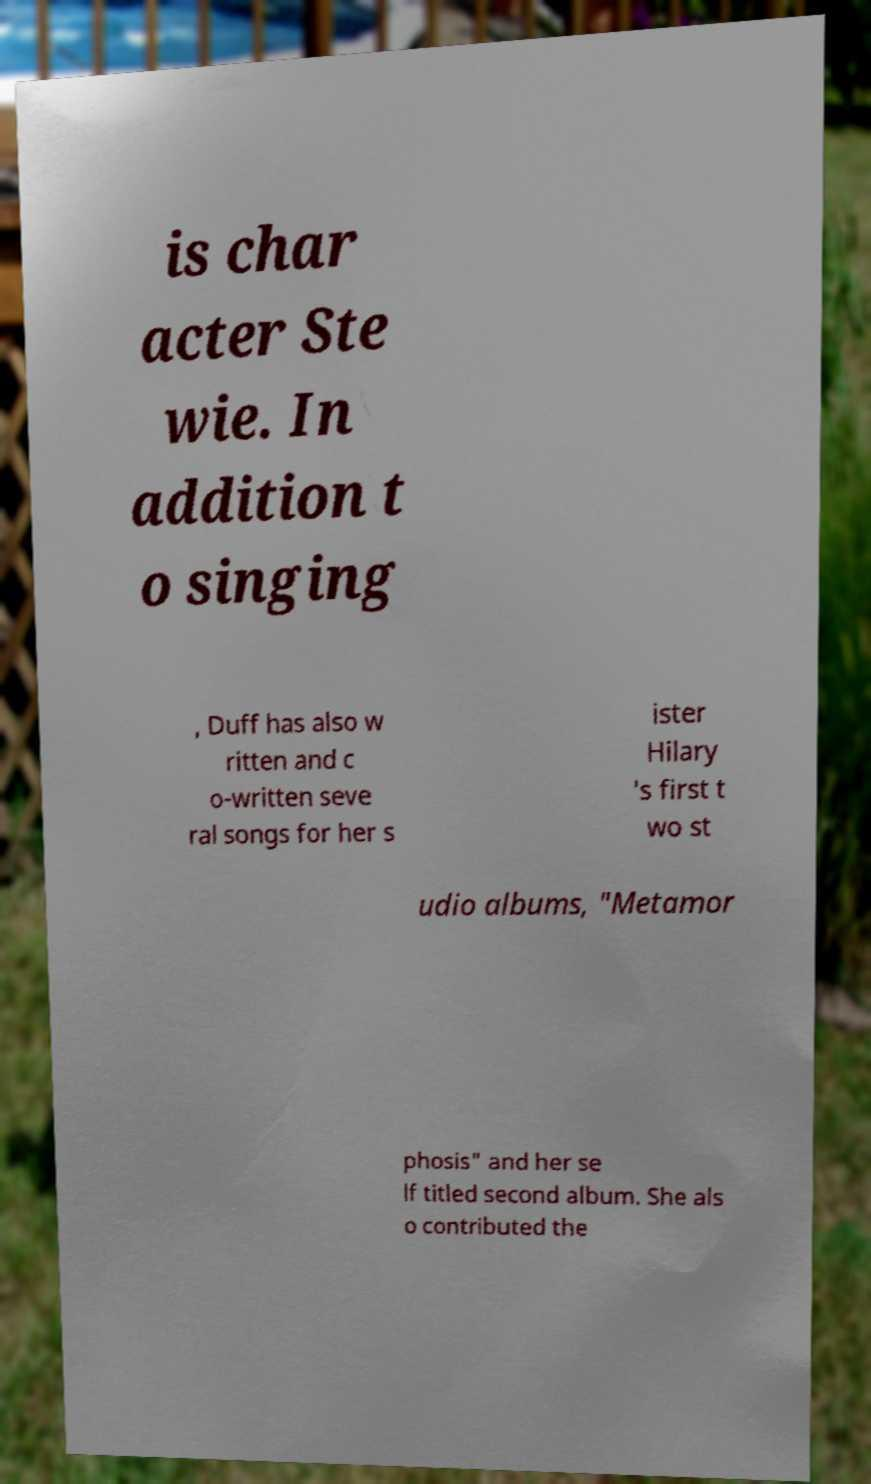Please read and relay the text visible in this image. What does it say? is char acter Ste wie. In addition t o singing , Duff has also w ritten and c o-written seve ral songs for her s ister Hilary 's first t wo st udio albums, "Metamor phosis" and her se lf titled second album. She als o contributed the 